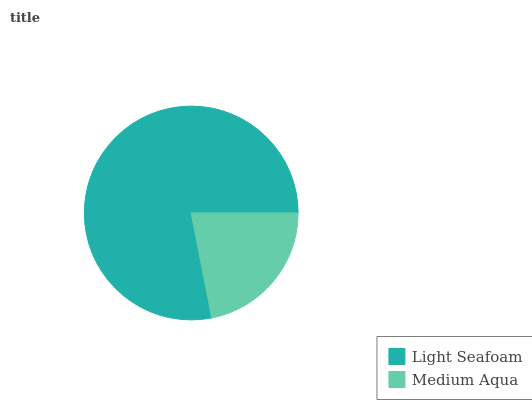Is Medium Aqua the minimum?
Answer yes or no. Yes. Is Light Seafoam the maximum?
Answer yes or no. Yes. Is Medium Aqua the maximum?
Answer yes or no. No. Is Light Seafoam greater than Medium Aqua?
Answer yes or no. Yes. Is Medium Aqua less than Light Seafoam?
Answer yes or no. Yes. Is Medium Aqua greater than Light Seafoam?
Answer yes or no. No. Is Light Seafoam less than Medium Aqua?
Answer yes or no. No. Is Light Seafoam the high median?
Answer yes or no. Yes. Is Medium Aqua the low median?
Answer yes or no. Yes. Is Medium Aqua the high median?
Answer yes or no. No. Is Light Seafoam the low median?
Answer yes or no. No. 